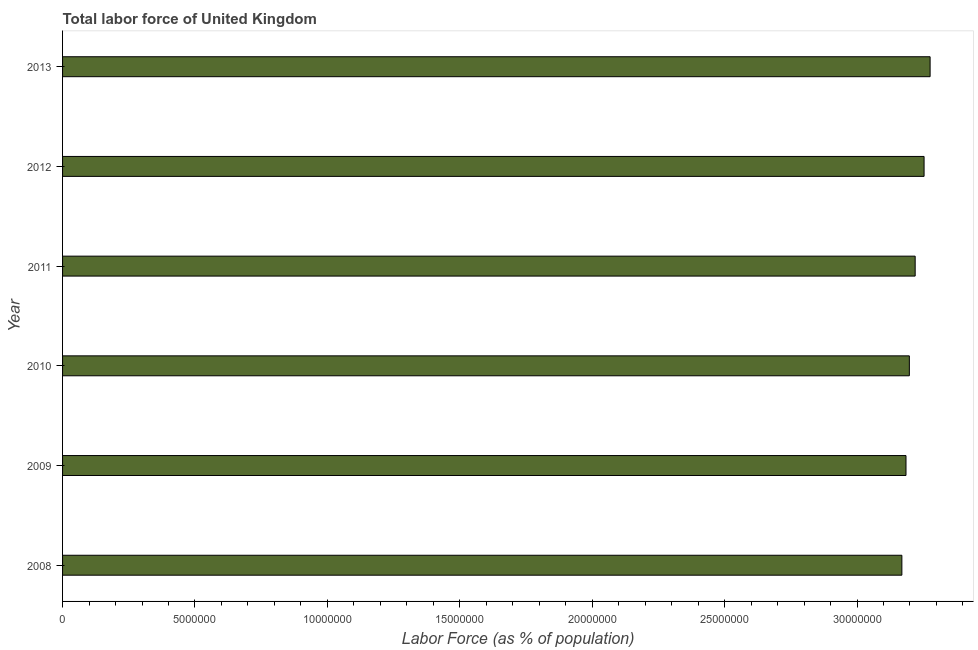What is the title of the graph?
Your answer should be very brief. Total labor force of United Kingdom. What is the label or title of the X-axis?
Offer a terse response. Labor Force (as % of population). What is the total labor force in 2012?
Ensure brevity in your answer.  3.25e+07. Across all years, what is the maximum total labor force?
Your answer should be very brief. 3.28e+07. Across all years, what is the minimum total labor force?
Make the answer very short. 3.17e+07. In which year was the total labor force maximum?
Keep it short and to the point. 2013. What is the sum of the total labor force?
Ensure brevity in your answer.  1.93e+08. What is the difference between the total labor force in 2008 and 2012?
Offer a terse response. -8.38e+05. What is the average total labor force per year?
Give a very brief answer. 3.22e+07. What is the median total labor force?
Offer a very short reply. 3.21e+07. Do a majority of the years between 2008 and 2010 (inclusive) have total labor force greater than 27000000 %?
Your answer should be very brief. Yes. What is the ratio of the total labor force in 2009 to that in 2012?
Ensure brevity in your answer.  0.98. What is the difference between the highest and the second highest total labor force?
Provide a short and direct response. 2.28e+05. Is the sum of the total labor force in 2011 and 2013 greater than the maximum total labor force across all years?
Provide a short and direct response. Yes. What is the difference between the highest and the lowest total labor force?
Ensure brevity in your answer.  1.07e+06. Are all the bars in the graph horizontal?
Provide a succinct answer. Yes. Are the values on the major ticks of X-axis written in scientific E-notation?
Provide a succinct answer. No. What is the Labor Force (as % of population) of 2008?
Your answer should be very brief. 3.17e+07. What is the Labor Force (as % of population) of 2009?
Offer a terse response. 3.19e+07. What is the Labor Force (as % of population) of 2010?
Make the answer very short. 3.20e+07. What is the Labor Force (as % of population) in 2011?
Make the answer very short. 3.22e+07. What is the Labor Force (as % of population) in 2012?
Provide a succinct answer. 3.25e+07. What is the Labor Force (as % of population) of 2013?
Keep it short and to the point. 3.28e+07. What is the difference between the Labor Force (as % of population) in 2008 and 2009?
Your answer should be very brief. -1.55e+05. What is the difference between the Labor Force (as % of population) in 2008 and 2010?
Make the answer very short. -2.82e+05. What is the difference between the Labor Force (as % of population) in 2008 and 2011?
Provide a succinct answer. -5.02e+05. What is the difference between the Labor Force (as % of population) in 2008 and 2012?
Keep it short and to the point. -8.38e+05. What is the difference between the Labor Force (as % of population) in 2008 and 2013?
Keep it short and to the point. -1.07e+06. What is the difference between the Labor Force (as % of population) in 2009 and 2010?
Your answer should be compact. -1.27e+05. What is the difference between the Labor Force (as % of population) in 2009 and 2011?
Provide a short and direct response. -3.47e+05. What is the difference between the Labor Force (as % of population) in 2009 and 2012?
Offer a terse response. -6.83e+05. What is the difference between the Labor Force (as % of population) in 2009 and 2013?
Provide a short and direct response. -9.11e+05. What is the difference between the Labor Force (as % of population) in 2010 and 2011?
Your answer should be compact. -2.20e+05. What is the difference between the Labor Force (as % of population) in 2010 and 2012?
Offer a very short reply. -5.56e+05. What is the difference between the Labor Force (as % of population) in 2010 and 2013?
Ensure brevity in your answer.  -7.84e+05. What is the difference between the Labor Force (as % of population) in 2011 and 2012?
Ensure brevity in your answer.  -3.36e+05. What is the difference between the Labor Force (as % of population) in 2011 and 2013?
Your answer should be compact. -5.64e+05. What is the difference between the Labor Force (as % of population) in 2012 and 2013?
Keep it short and to the point. -2.28e+05. What is the ratio of the Labor Force (as % of population) in 2008 to that in 2010?
Keep it short and to the point. 0.99. What is the ratio of the Labor Force (as % of population) in 2008 to that in 2012?
Ensure brevity in your answer.  0.97. What is the ratio of the Labor Force (as % of population) in 2008 to that in 2013?
Offer a terse response. 0.97. What is the ratio of the Labor Force (as % of population) in 2009 to that in 2010?
Provide a short and direct response. 1. What is the ratio of the Labor Force (as % of population) in 2009 to that in 2011?
Your answer should be compact. 0.99. 